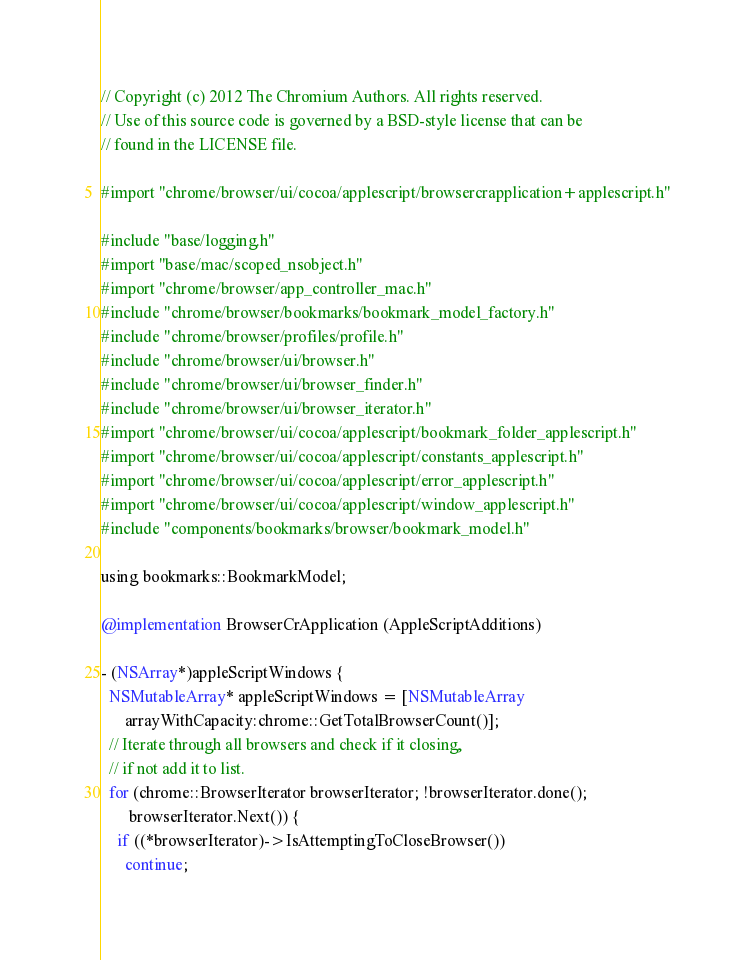Convert code to text. <code><loc_0><loc_0><loc_500><loc_500><_ObjectiveC_>// Copyright (c) 2012 The Chromium Authors. All rights reserved.
// Use of this source code is governed by a BSD-style license that can be
// found in the LICENSE file.

#import "chrome/browser/ui/cocoa/applescript/browsercrapplication+applescript.h"

#include "base/logging.h"
#import "base/mac/scoped_nsobject.h"
#import "chrome/browser/app_controller_mac.h"
#include "chrome/browser/bookmarks/bookmark_model_factory.h"
#include "chrome/browser/profiles/profile.h"
#include "chrome/browser/ui/browser.h"
#include "chrome/browser/ui/browser_finder.h"
#include "chrome/browser/ui/browser_iterator.h"
#import "chrome/browser/ui/cocoa/applescript/bookmark_folder_applescript.h"
#import "chrome/browser/ui/cocoa/applescript/constants_applescript.h"
#import "chrome/browser/ui/cocoa/applescript/error_applescript.h"
#import "chrome/browser/ui/cocoa/applescript/window_applescript.h"
#include "components/bookmarks/browser/bookmark_model.h"

using bookmarks::BookmarkModel;

@implementation BrowserCrApplication (AppleScriptAdditions)

- (NSArray*)appleScriptWindows {
  NSMutableArray* appleScriptWindows = [NSMutableArray
      arrayWithCapacity:chrome::GetTotalBrowserCount()];
  // Iterate through all browsers and check if it closing,
  // if not add it to list.
  for (chrome::BrowserIterator browserIterator; !browserIterator.done();
       browserIterator.Next()) {
    if ((*browserIterator)->IsAttemptingToCloseBrowser())
      continue;
</code> 